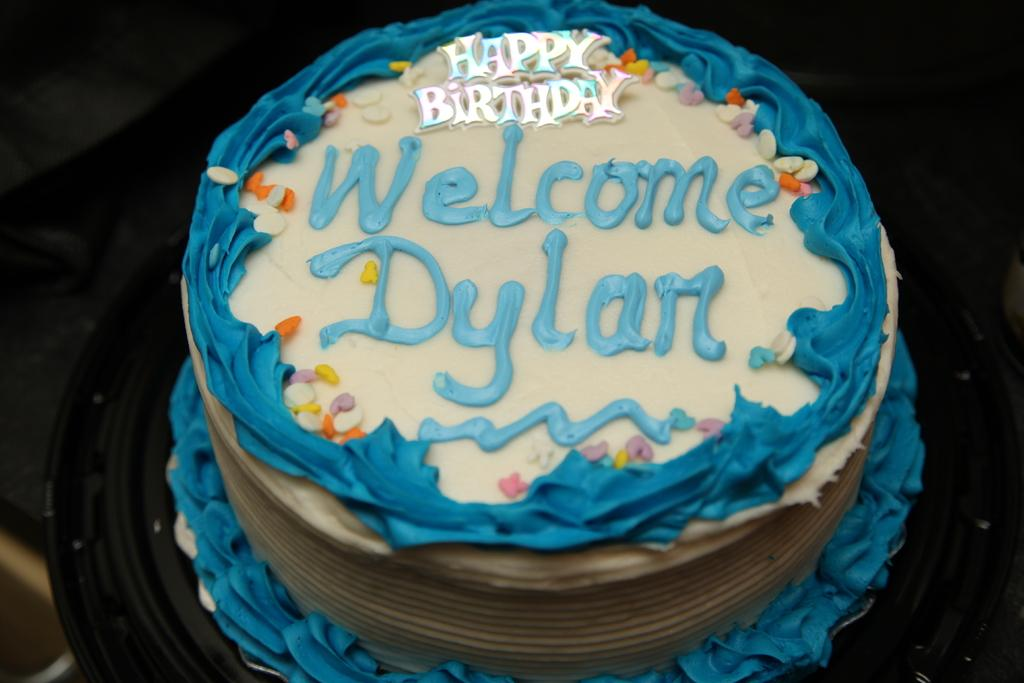What is the main subject of the image? The main subject of the image is a cake. Can you describe any specific details about the cake? Yes, the cake has some text on it. What can be observed about the overall appearance of the image? The background of the image is dark. How does the feeling of the cake change throughout the image? There is no indication of a feeling or emotion associated with the cake in the image. --- Facts: 1. There is a car in the image. 2. The car is red. 3. The car has four wheels. 4. There are people in the car. 5. The car is parked on the street. Absurd Topics: fish, ocean, wave Conversation: What is the main subject of the image? The main subject of the image is a car. Can you describe the appearance of the car? Yes, the car is red and has four wheels. Are there any people inside the car? Yes, there are people in the car. Where is the car located in the image? The car is parked on the street. Reasoning: Let's think step by step in order to produce the conversation. We start by identifying the main subject of the image, which is the car. Next, we describe the appearance of the car, including its color and the number of wheels. Then, we mention the presence of people inside the car. Finally, we describe the location of the car, which is parked on the street. Absurd Question/Answer: Can you see any fish swimming in the ocean in the image? There is no ocean or fish present in the image; it features a red car parked on the street with people inside. 